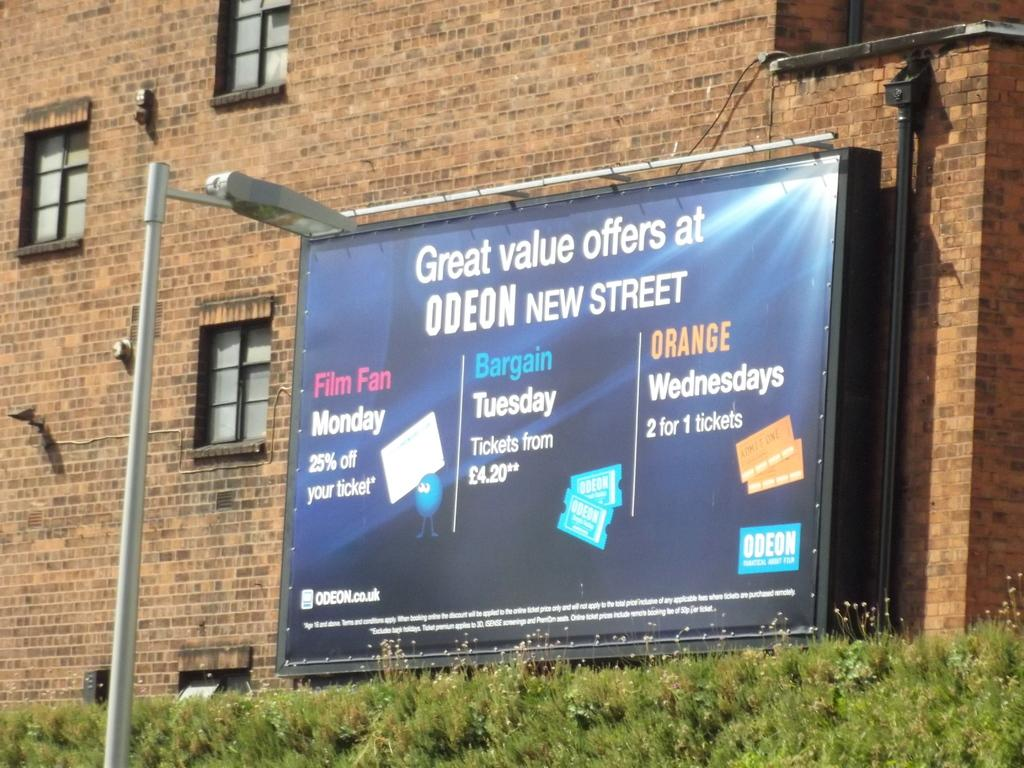<image>
Render a clear and concise summary of the photo. a billboard for Great Value Offers at Odeon New Street 